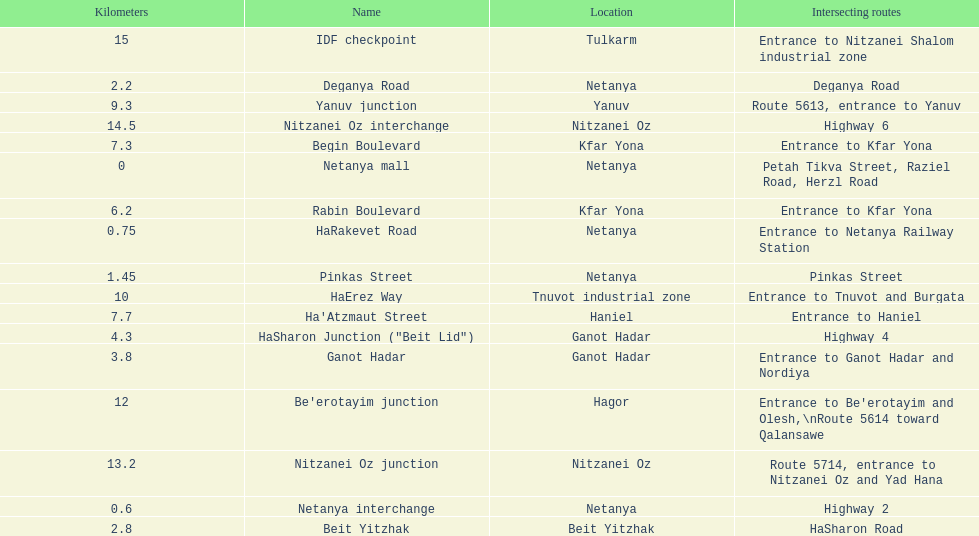Which portion has the same intersecting route as rabin boulevard? Begin Boulevard. 